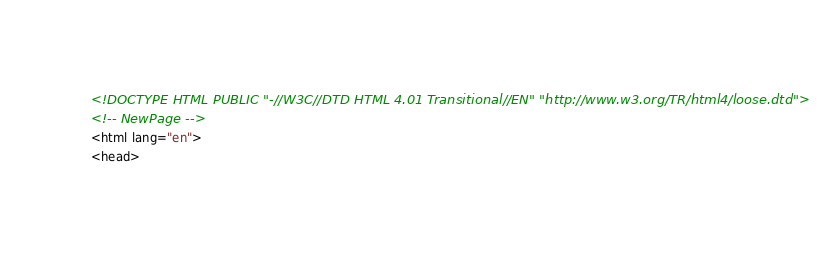<code> <loc_0><loc_0><loc_500><loc_500><_HTML_><!DOCTYPE HTML PUBLIC "-//W3C//DTD HTML 4.01 Transitional//EN" "http://www.w3.org/TR/html4/loose.dtd">
<!-- NewPage -->
<html lang="en">
<head></code> 